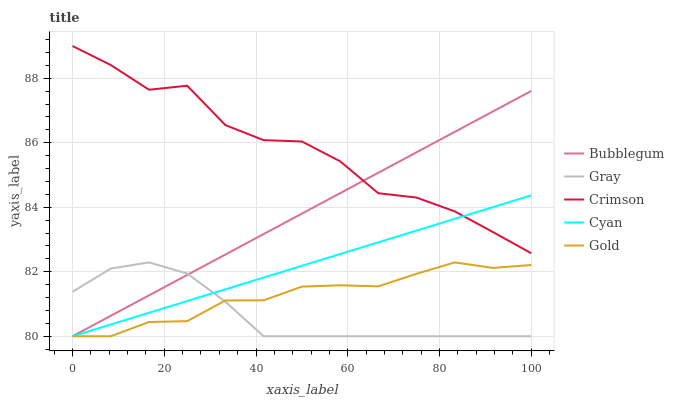Does Gray have the minimum area under the curve?
Answer yes or no. Yes. Does Crimson have the maximum area under the curve?
Answer yes or no. Yes. Does Gold have the minimum area under the curve?
Answer yes or no. No. Does Gold have the maximum area under the curve?
Answer yes or no. No. Is Bubblegum the smoothest?
Answer yes or no. Yes. Is Crimson the roughest?
Answer yes or no. Yes. Is Gray the smoothest?
Answer yes or no. No. Is Gray the roughest?
Answer yes or no. No. Does Gray have the lowest value?
Answer yes or no. Yes. Does Crimson have the highest value?
Answer yes or no. Yes. Does Gold have the highest value?
Answer yes or no. No. Is Gray less than Crimson?
Answer yes or no. Yes. Is Crimson greater than Gray?
Answer yes or no. Yes. Does Cyan intersect Bubblegum?
Answer yes or no. Yes. Is Cyan less than Bubblegum?
Answer yes or no. No. Is Cyan greater than Bubblegum?
Answer yes or no. No. Does Gray intersect Crimson?
Answer yes or no. No. 